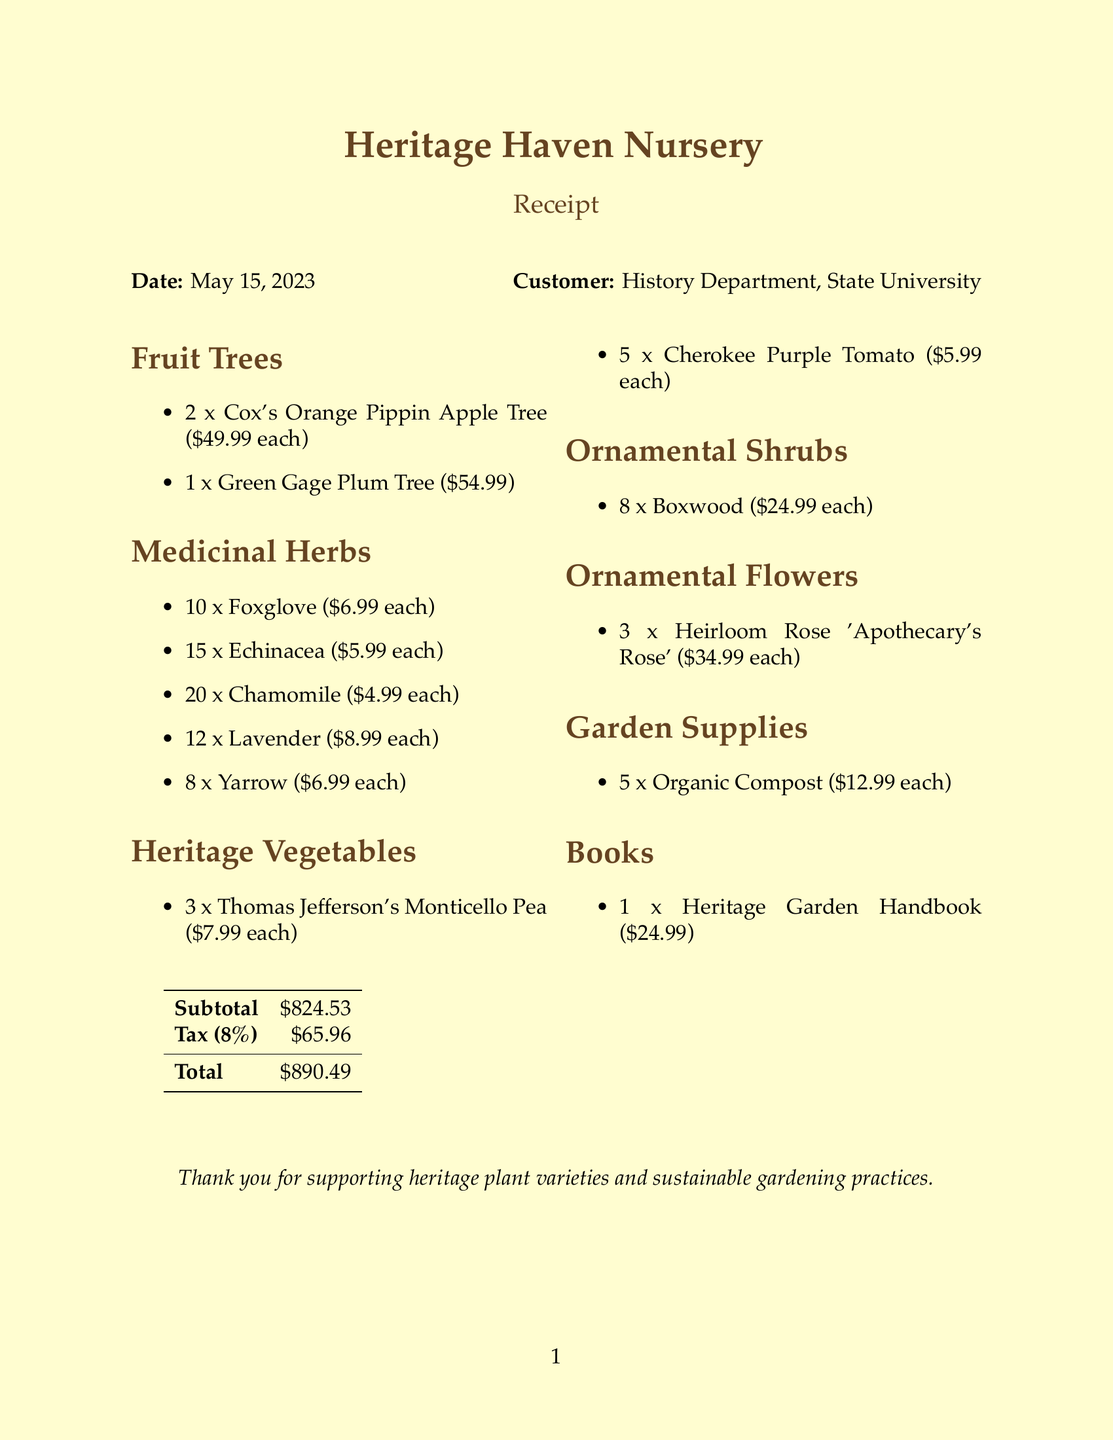What is the name of the nursery? The nursery name is mentioned at the top of the document.
Answer: Heritage Haven Nursery What is the date of the purchase? The date is provided prominently at the top of the receipt.
Answer: May 15, 2023 How many Cox's Orange Pippin Apple Trees were purchased? This information is found in the Fruit Trees section of the document.
Answer: 2 What is the total amount paid including tax? The total amount is calculated and listed at the end of the receipt.
Answer: $890.49 How many types of medicinal herbs were purchased? This is determined by counting the different items in the Medicinal Herbs section.
Answer: 5 What was the unit price of Echinacea? The unit price of Echinacea is specified in the Medicinal Herbs section.
Answer: $5.99 What category does the item 'Heirloom Rose 'Apothecary's Rose'' belong to? The category is noted next to the item in the Ornamental Flowers section.
Answer: Ornamental Flowers How many items were purchased in total? This is the sum of quantities across all items listed in the document.
Answer: 76 What is the subtotal before tax? The subtotal is presented in a tabular format towards the bottom of the receipt.
Answer: $824.53 